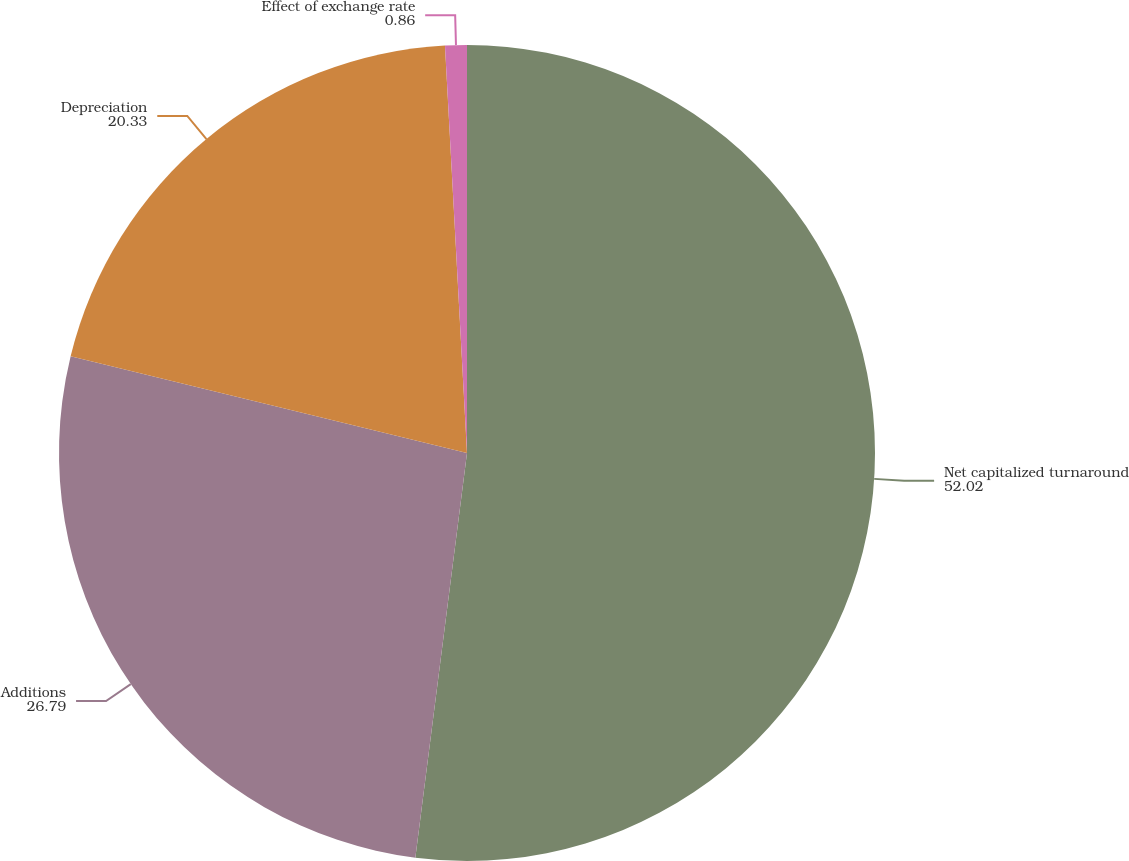Convert chart to OTSL. <chart><loc_0><loc_0><loc_500><loc_500><pie_chart><fcel>Net capitalized turnaround<fcel>Additions<fcel>Depreciation<fcel>Effect of exchange rate<nl><fcel>52.02%<fcel>26.79%<fcel>20.33%<fcel>0.86%<nl></chart> 